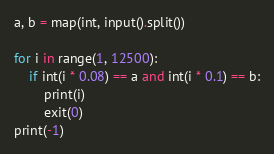<code> <loc_0><loc_0><loc_500><loc_500><_Python_>a, b = map(int, input().split())

for i in range(1, 12500):
    if int(i * 0.08) == a and int(i * 0.1) == b:
        print(i)
        exit(0)
print(-1)
</code> 